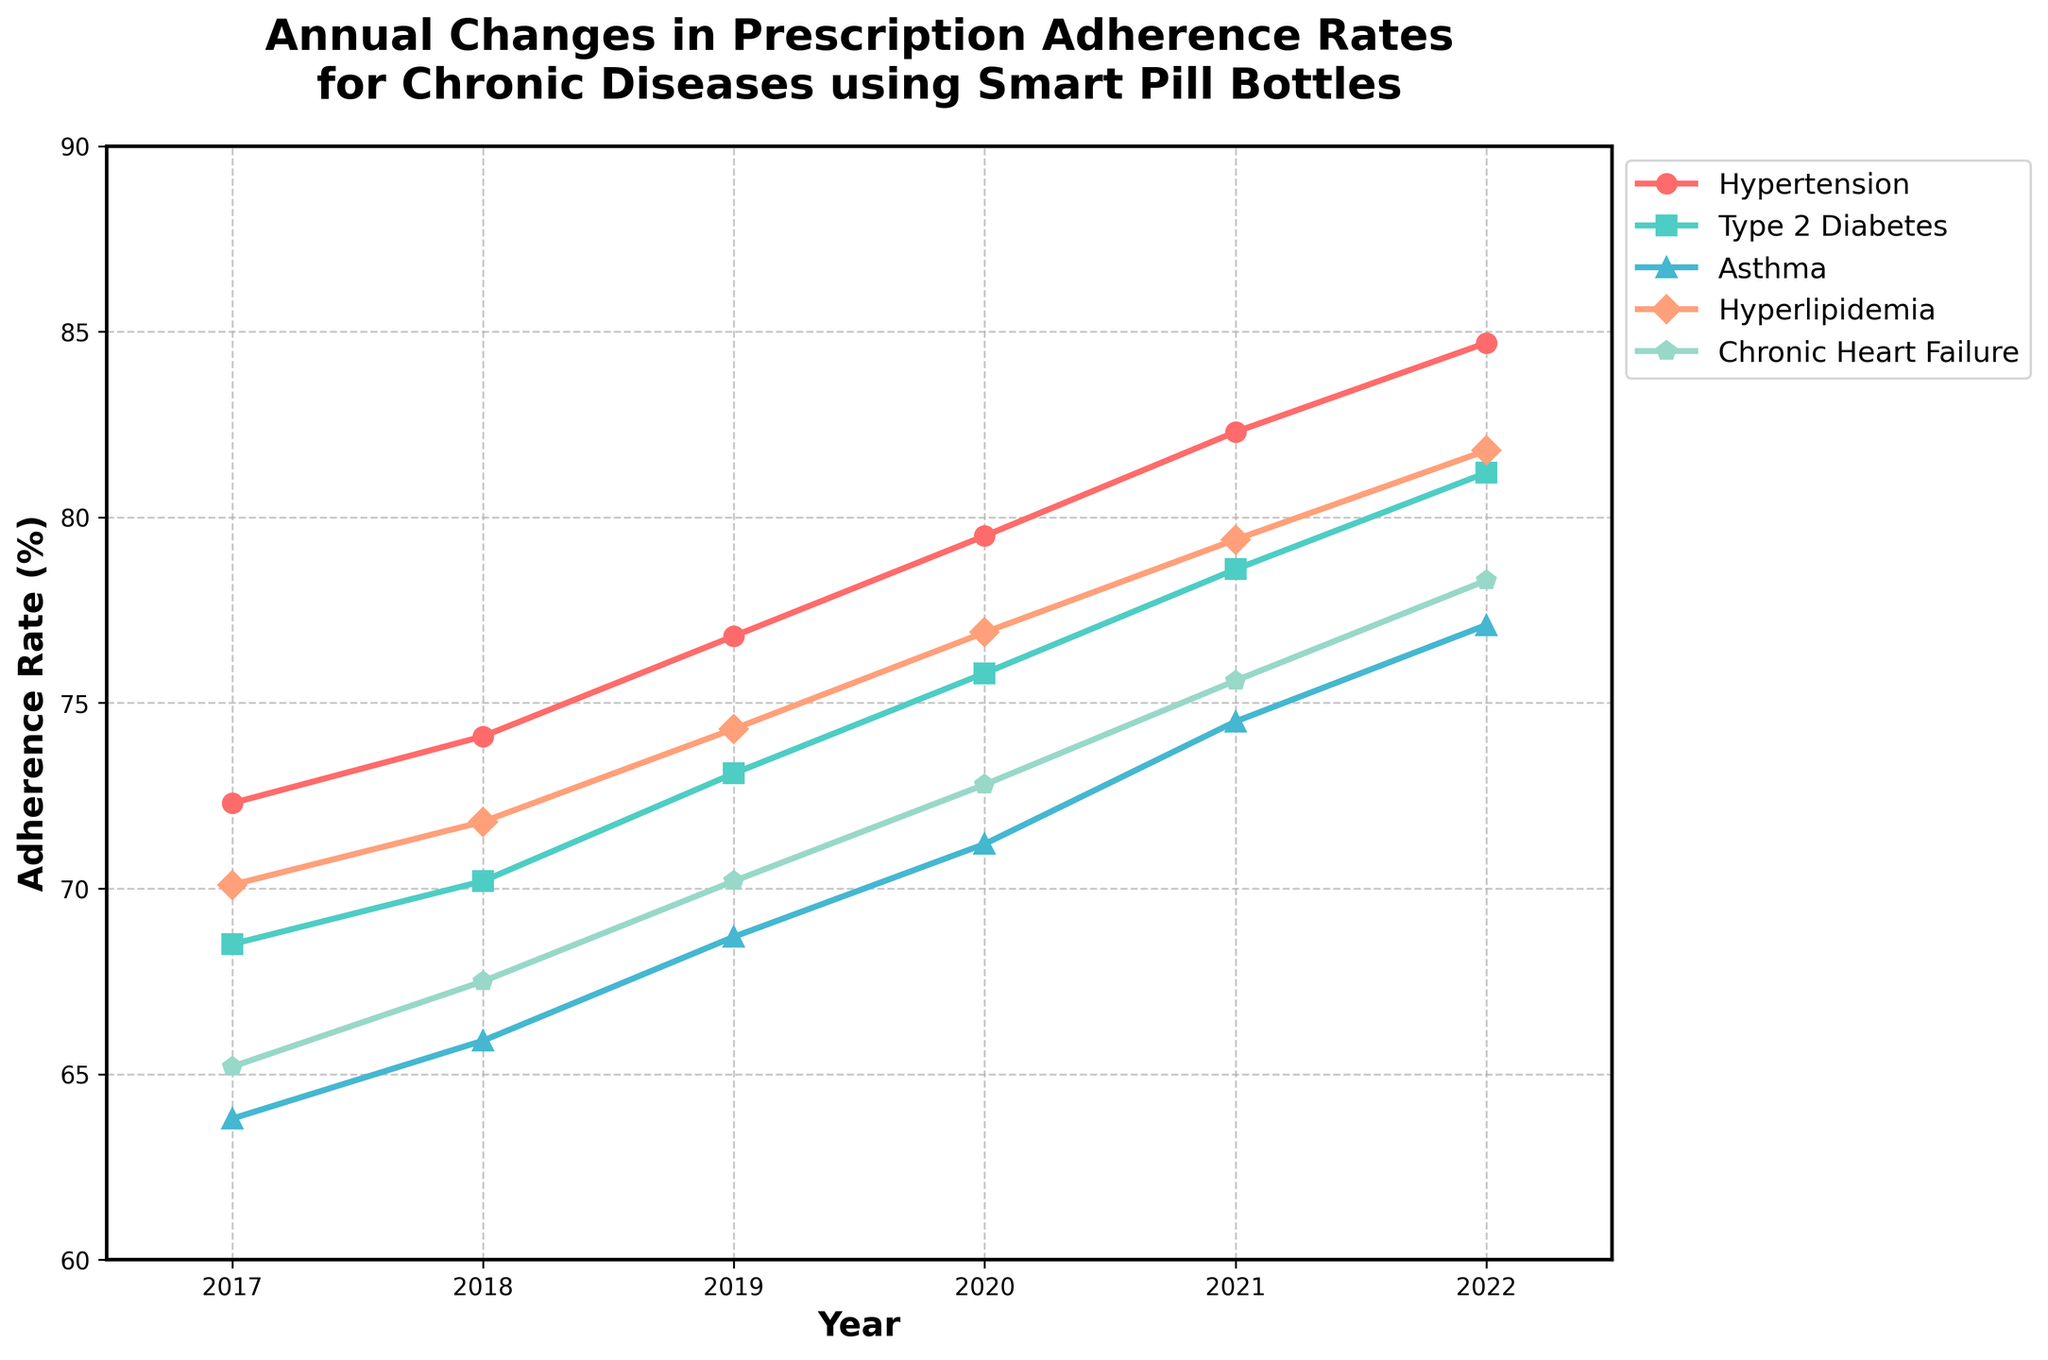What's the trend of prescription adherence rates for Hypertension from 2017 to 2022? Look at the line corresponding to Hypertension and observe its direction from 2017 to 2022. The adherence rate increases steadily every year.
Answer: Increasing Which disease had the highest adherence rate in 2022? Check the adherence rates for all diseases in 2022. The highest value is for Hypertension, at 84.7%.
Answer: Hypertension Compare the adherence rates for Type 2 Diabetes and Asthma in 2019. Which one is higher and by how much? Find the adherence rates for Type 2 Diabetes (73.1%) and Asthma (68.7%) in 2019. Type 2 Diabetes is higher. Subtract 68.7 from 73.1 to get the difference.
Answer: Type 2 Diabetes, 4.4% What is the average adherence rate for Hyperlipidemia over the years? Sum up the adherence rates for Hyperlipidemia from 2017 to 2022 and divide by the number of years (6). (70.1 + 71.8 + 74.3 + 76.9 + 79.4 + 81.8) / 6 = 75.72%
Answer: 75.72% Which disease showed the greatest improvement in prescription adherence from 2017 to 2022? Calculate the difference in adherence rates for each disease between 2017 and 2022. The disease with the largest difference is Asthma (77.1% - 63.8% = 13.3%).
Answer: Asthma What color represents Chronic Heart Failure in the chart? Look at the legend to identify the color corresponding to Chronic Heart Failure.
Answer: Light blue Did the adherence rate for Hyperlipidemia ever decrease from one year to the next in the given period? Look at the adherence rates for Hyperlipidemia year by year and check if there is any drop. Each year shows an increase.
Answer: No Calculate the total increase in adherence rate for Asthma from 2017 to 2021. Subtract the 2017 adherence rate from the 2021 adherence rate for Asthma (74.5% - 63.8% = 10.7%).
Answer: 10.7% What is the median adherence rate for Hypertension from 2017 to 2022? List the adherence rates for Hypertension from 2017 to 2022 and find the median, which is the middle value in the sorted list: 72.3, 74.1, 76.8, 79.5, 82.3, 84.7. The median of these 6 values (average of the 3rd and 4th values) is (76.8 + 79.5) / 2 = 78.15.
Answer: 78.15% 